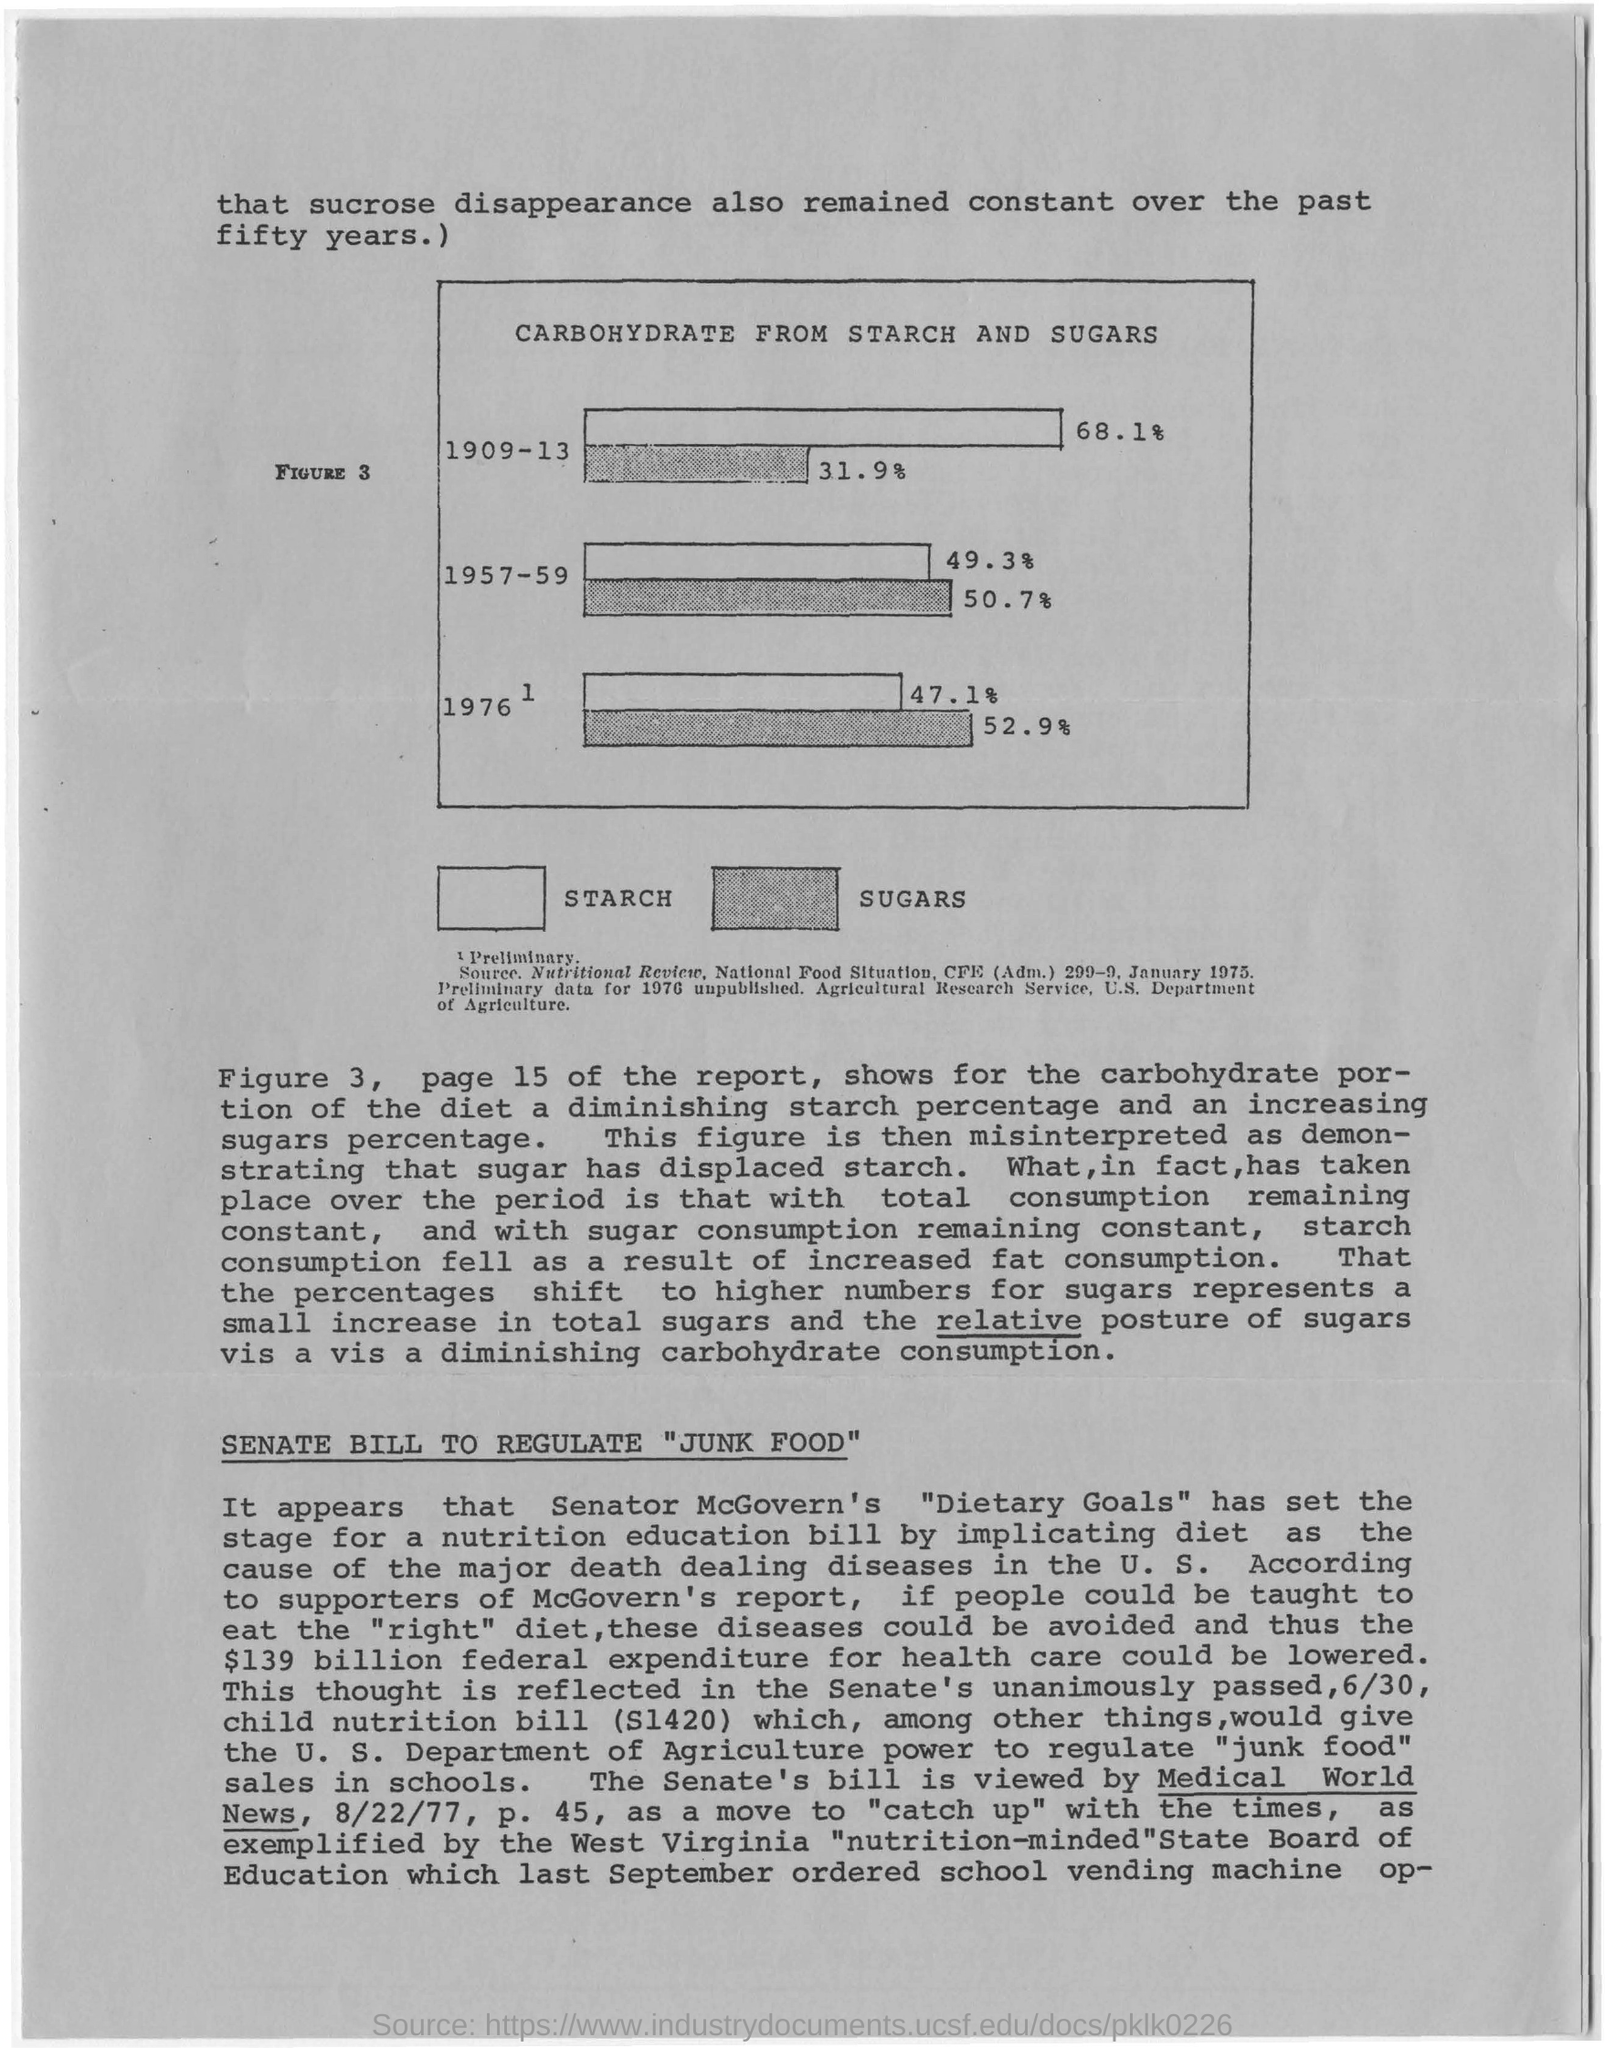Over how many years sucrose disappearance remained constant?
Provide a succinct answer. The past fifty years. Carbohydrate from starch was high in which years?
Keep it short and to the point. 1909-13. Which page of the report is referred?
Provide a succinct answer. 15. In 1976 how much is the carbohydrate from sugars?
Your answer should be very brief. 52.9 %. 